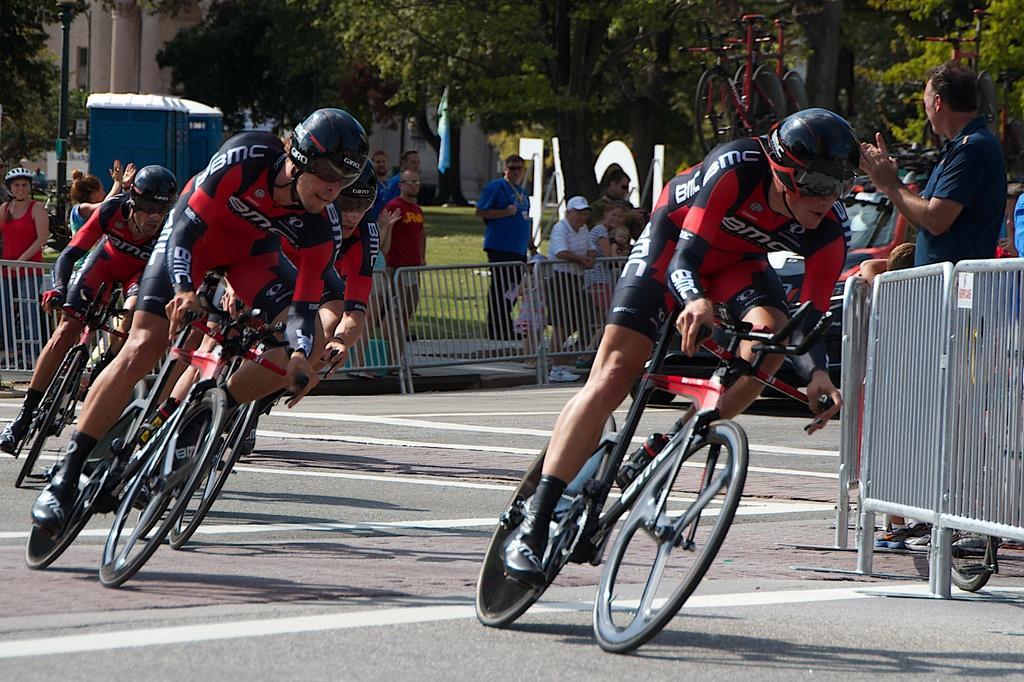Can you describe this image briefly? In this picture there is a person who riding a bicycle. Players are wearing a red color dress and helmet. On the backside we can see a fencing. Over their there is a public was standing on a park and watching a bicycle racing. On the top we can see a tree. On the left there is a pole. On the background we can see a car. 